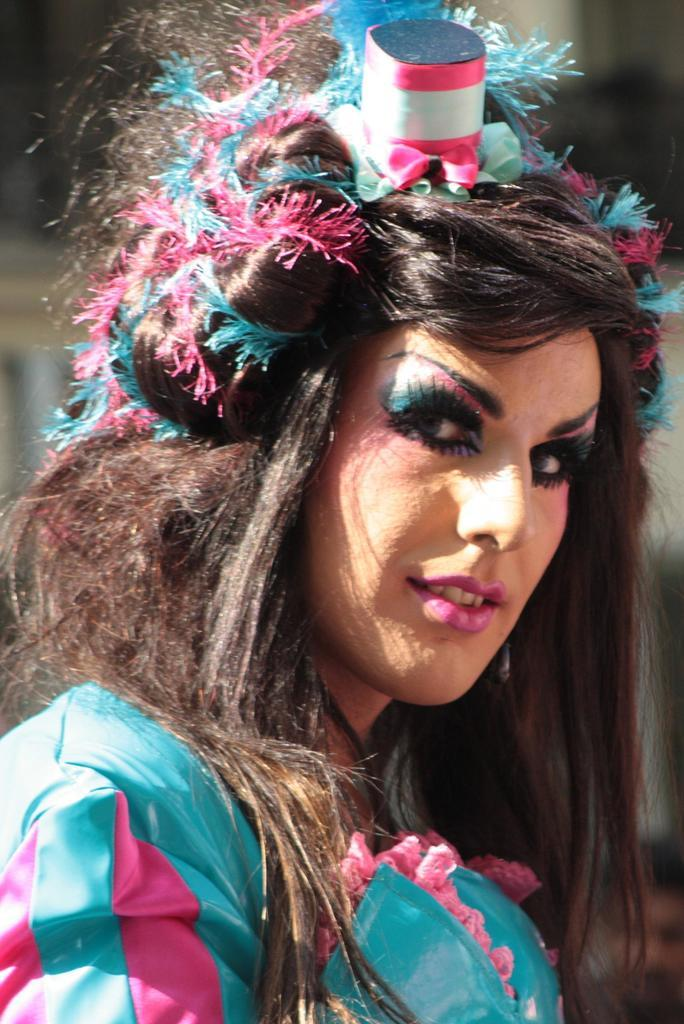What is the woman doing in the image? The woman is standing on her head in the image. Is there anything else in the image related to the woman? Yes, there is an object trying to her hair. What can be observed about the woman's facial features? The woman's eyebrows and eyes are colored. How many chairs are visible in the image? There are no chairs present in the image. Can you see any jellyfish in the image? There are no jellyfish present in the image. 